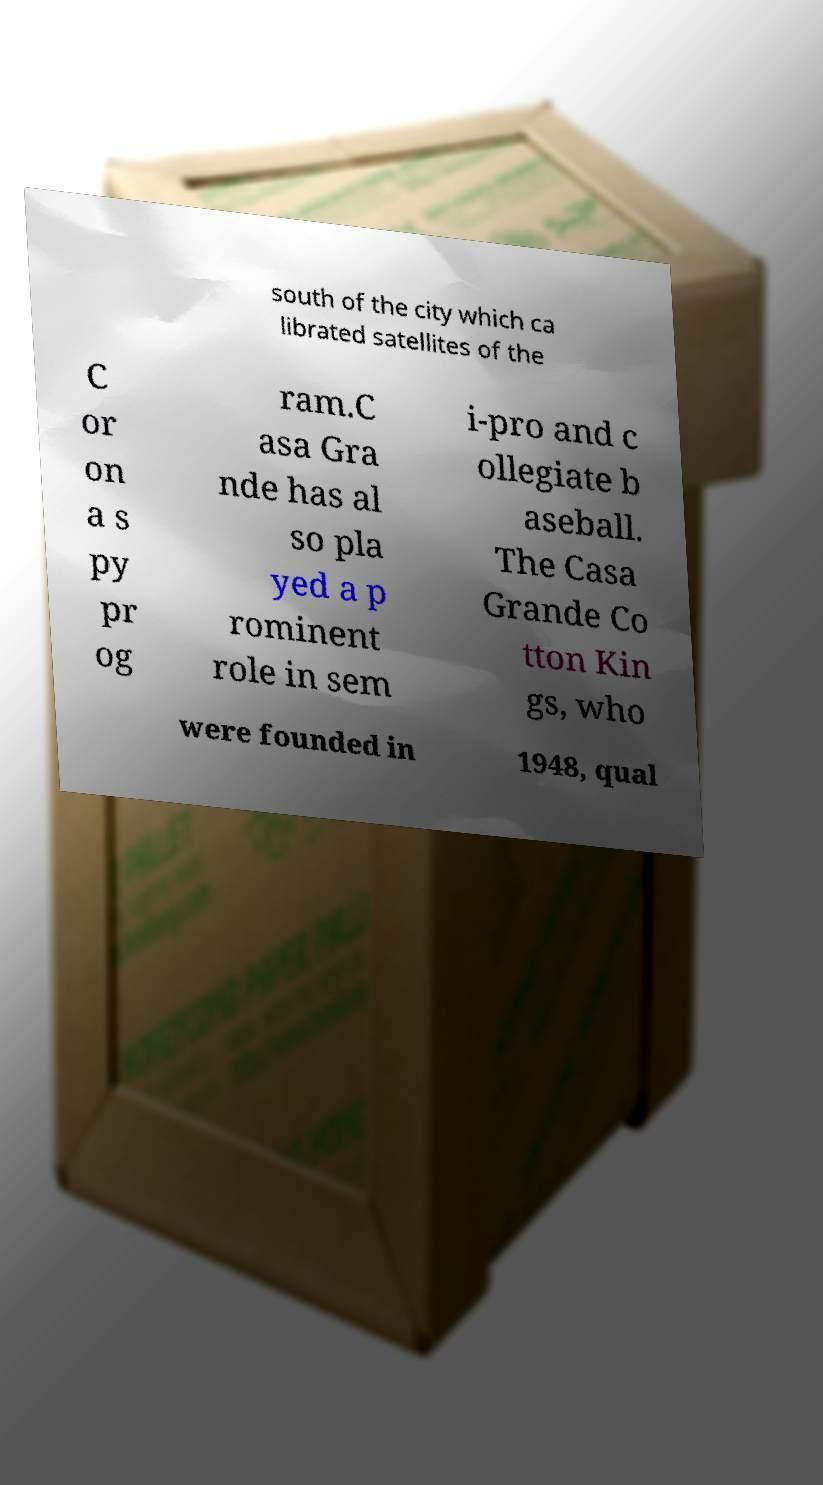Could you assist in decoding the text presented in this image and type it out clearly? south of the city which ca librated satellites of the C or on a s py pr og ram.C asa Gra nde has al so pla yed a p rominent role in sem i-pro and c ollegiate b aseball. The Casa Grande Co tton Kin gs, who were founded in 1948, qual 